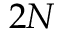Convert formula to latex. <formula><loc_0><loc_0><loc_500><loc_500>2 N</formula> 